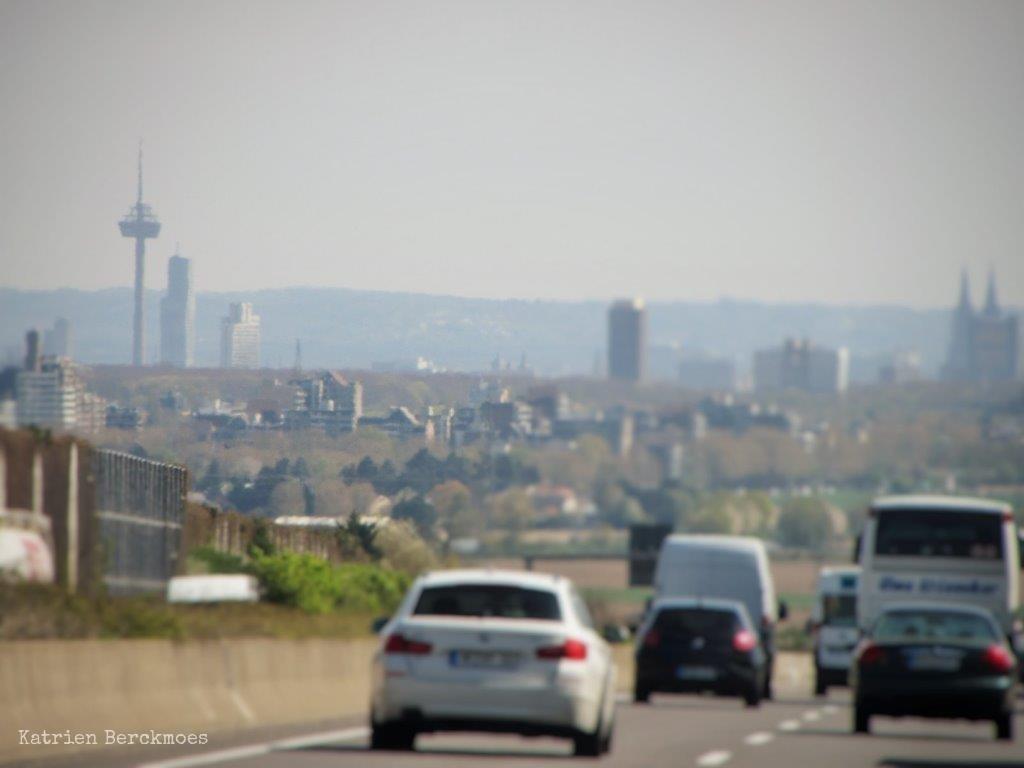In one or two sentences, can you explain what this image depicts? In this image we can see cars travelling on the road, beside there are trees, there is a fence, in front there are buildings, there are mountains, there is sky at the top. 